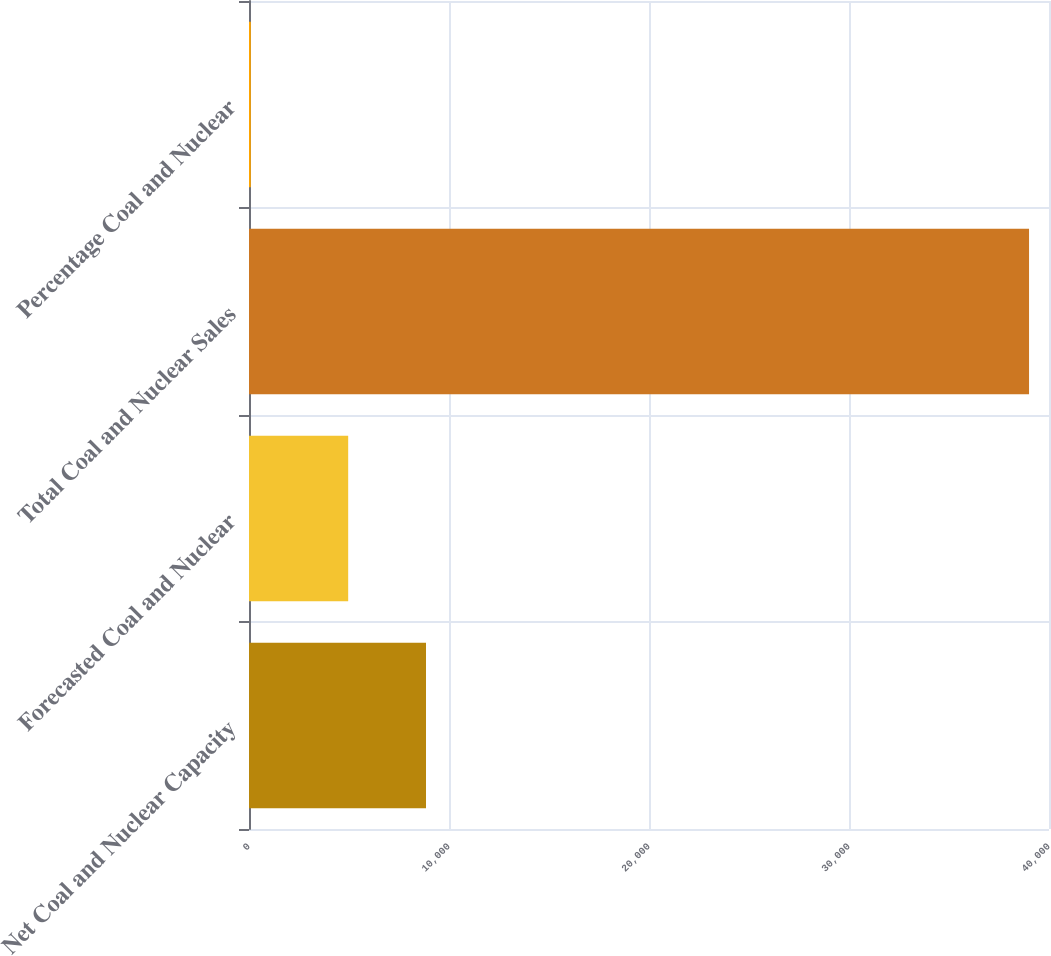<chart> <loc_0><loc_0><loc_500><loc_500><bar_chart><fcel>Net Coal and Nuclear Capacity<fcel>Forecasted Coal and Nuclear<fcel>Total Coal and Nuclear Sales<fcel>Percentage Coal and Nuclear<nl><fcel>8850.2<fcel>4959<fcel>39002<fcel>90<nl></chart> 